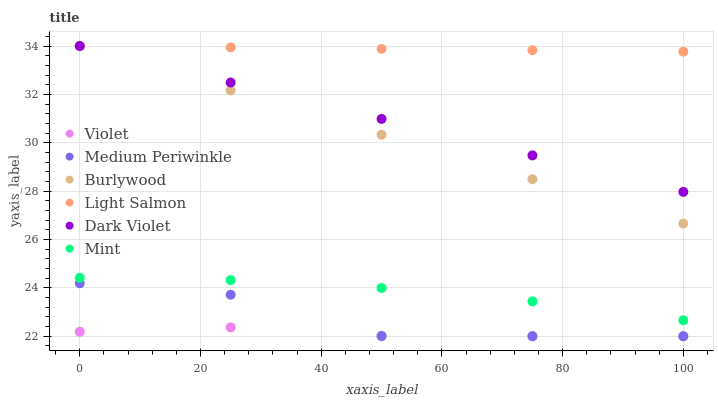Does Violet have the minimum area under the curve?
Answer yes or no. Yes. Does Light Salmon have the maximum area under the curve?
Answer yes or no. Yes. Does Burlywood have the minimum area under the curve?
Answer yes or no. No. Does Burlywood have the maximum area under the curve?
Answer yes or no. No. Is Burlywood the smoothest?
Answer yes or no. Yes. Is Medium Periwinkle the roughest?
Answer yes or no. Yes. Is Medium Periwinkle the smoothest?
Answer yes or no. No. Is Burlywood the roughest?
Answer yes or no. No. Does Medium Periwinkle have the lowest value?
Answer yes or no. Yes. Does Burlywood have the lowest value?
Answer yes or no. No. Does Dark Violet have the highest value?
Answer yes or no. Yes. Does Medium Periwinkle have the highest value?
Answer yes or no. No. Is Violet less than Dark Violet?
Answer yes or no. Yes. Is Mint greater than Violet?
Answer yes or no. Yes. Does Medium Periwinkle intersect Violet?
Answer yes or no. Yes. Is Medium Periwinkle less than Violet?
Answer yes or no. No. Is Medium Periwinkle greater than Violet?
Answer yes or no. No. Does Violet intersect Dark Violet?
Answer yes or no. No. 